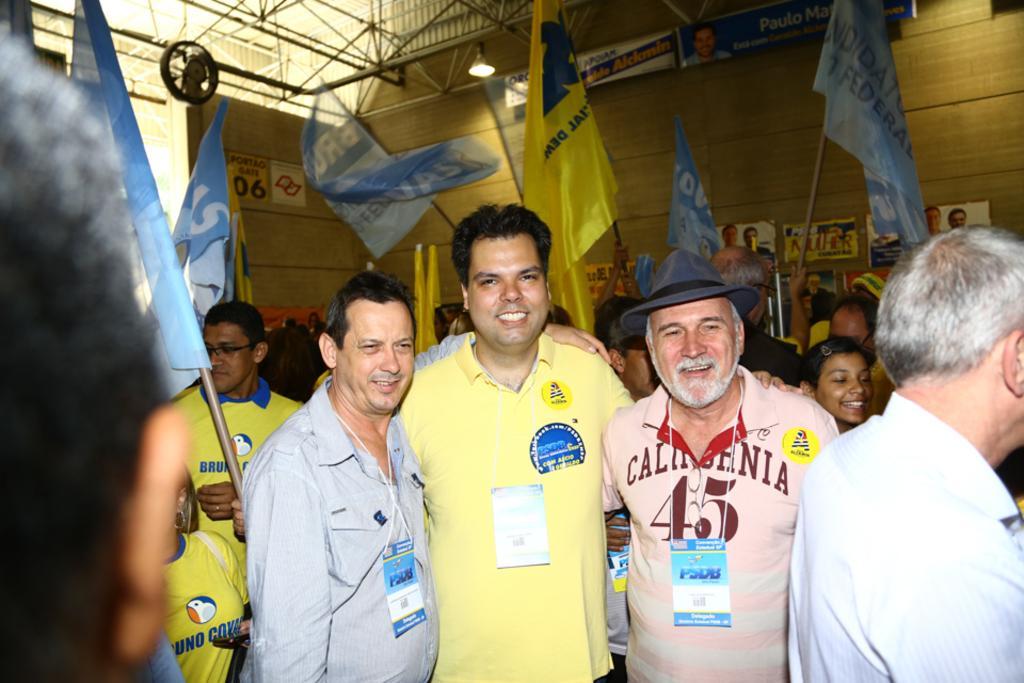Can you describe this image briefly? In this image in the front there are persons standing and smiling. In the background there are persons, there are flags and on the wall there are posters and there are boards with some text written on it. 